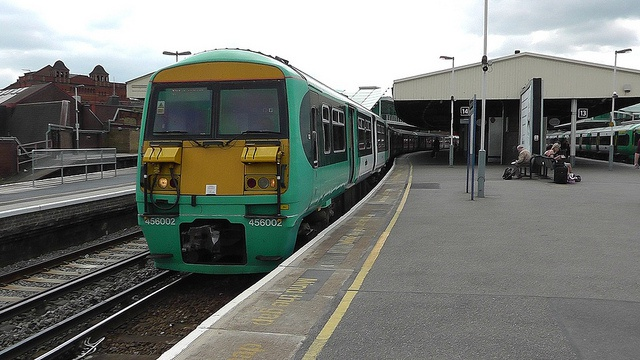Describe the objects in this image and their specific colors. I can see train in white, black, teal, gray, and olive tones, people in white, black, gray, and darkgray tones, people in white, black, gray, and darkgray tones, bench in white, black, and gray tones, and bench in white, black, and gray tones in this image. 